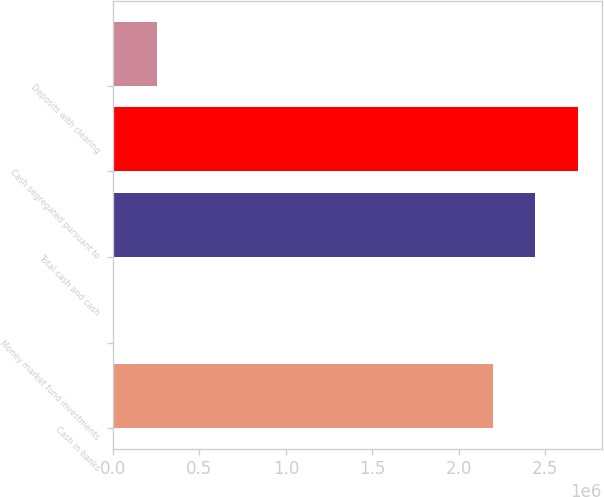Convert chart. <chart><loc_0><loc_0><loc_500><loc_500><bar_chart><fcel>Cash in banks<fcel>Money market fund investments<fcel>Total cash and cash<fcel>Cash segregated pursuant to<fcel>Deposits with clearing<nl><fcel>2.19568e+06<fcel>3380<fcel>2.44427e+06<fcel>2.69286e+06<fcel>251968<nl></chart> 